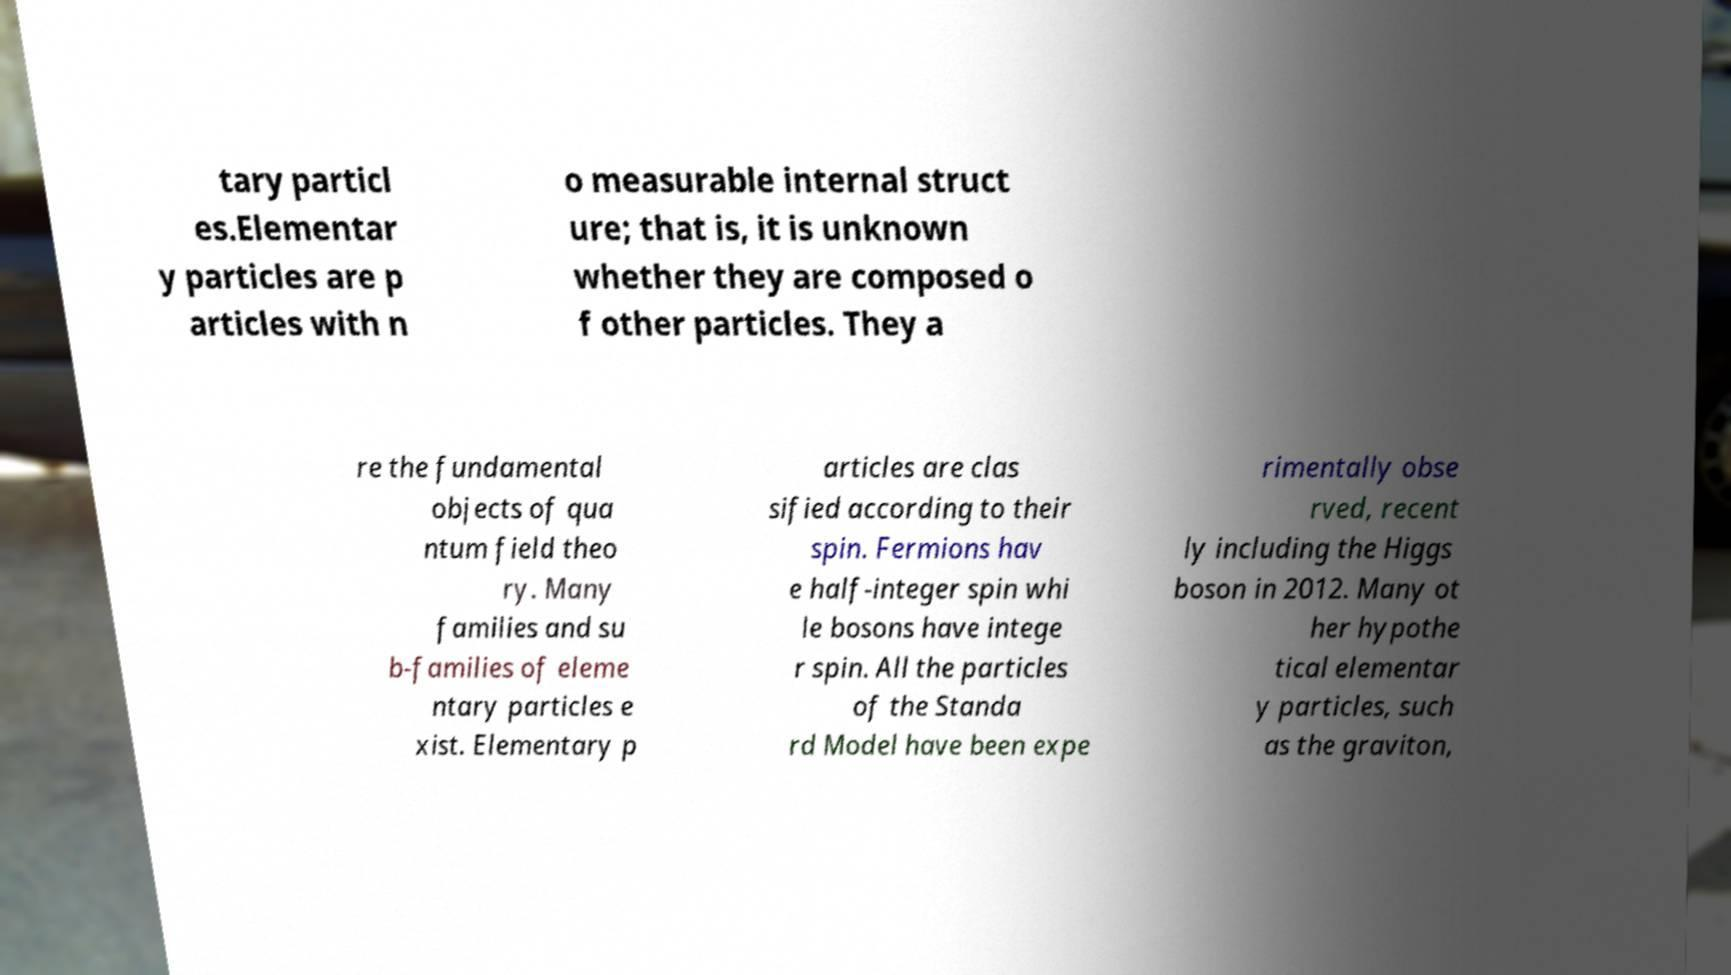Can you read and provide the text displayed in the image?This photo seems to have some interesting text. Can you extract and type it out for me? tary particl es.Elementar y particles are p articles with n o measurable internal struct ure; that is, it is unknown whether they are composed o f other particles. They a re the fundamental objects of qua ntum field theo ry. Many families and su b-families of eleme ntary particles e xist. Elementary p articles are clas sified according to their spin. Fermions hav e half-integer spin whi le bosons have intege r spin. All the particles of the Standa rd Model have been expe rimentally obse rved, recent ly including the Higgs boson in 2012. Many ot her hypothe tical elementar y particles, such as the graviton, 